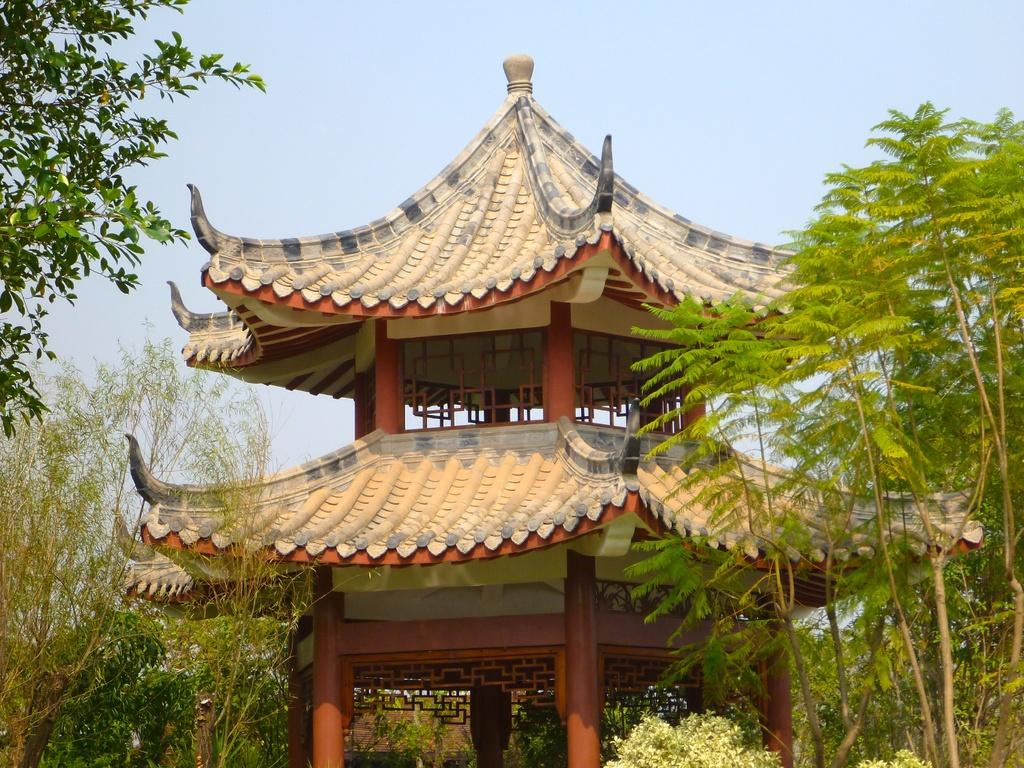What is the main subject in the middle of the image? There is a construction in the middle of the image. What type of natural elements can be seen in the image? There are trees in the image. What is visible at the top of the image? The sky is visible at the top of the image. What brand of toothpaste is advertised on the sign near the construction site? There is no sign or toothpaste mentioned in the image; it only features a construction site and trees. 